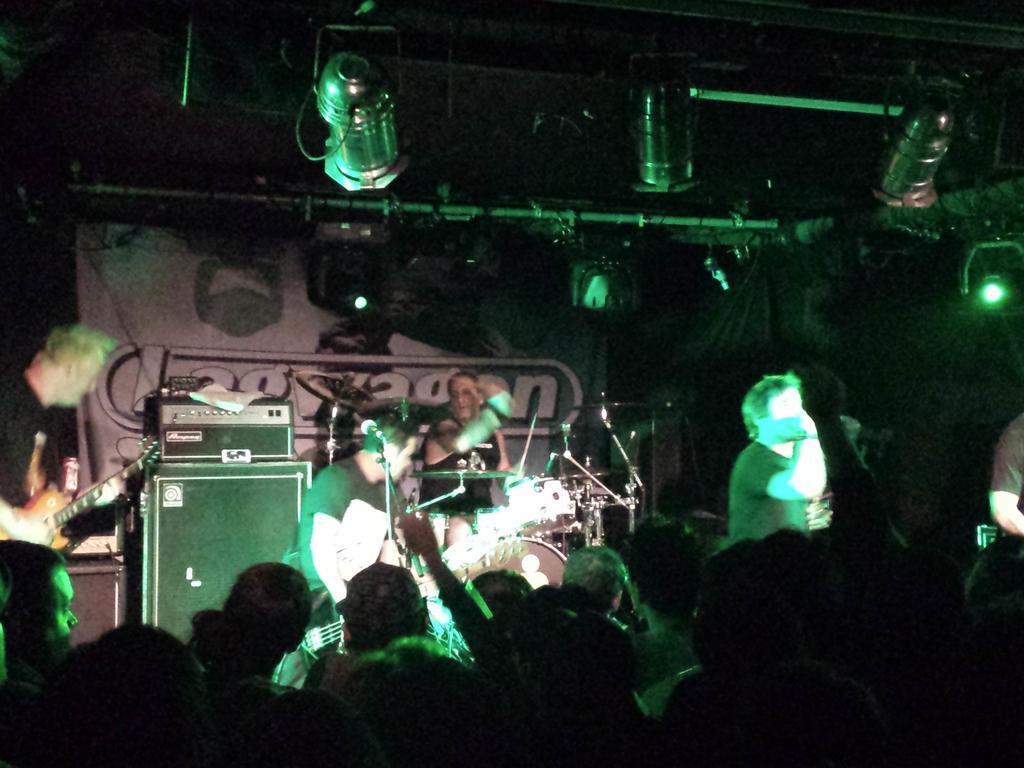Describe this image in one or two sentences. This picture shows a couple of them seated and playing musical instruments and we see few of them standing and we see a man playing guitar and other one singing with the help of a microphone and we see a man seated and playing drums and we see audience in front of them 